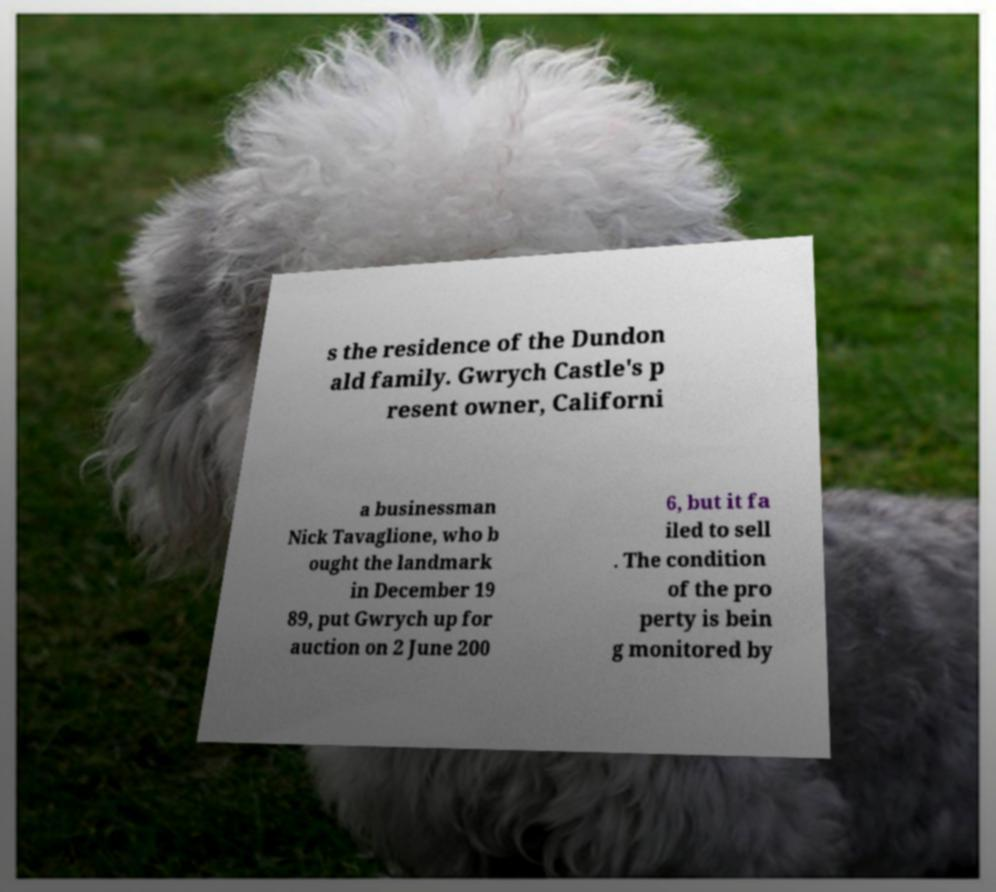I need the written content from this picture converted into text. Can you do that? s the residence of the Dundon ald family. Gwrych Castle's p resent owner, Californi a businessman Nick Tavaglione, who b ought the landmark in December 19 89, put Gwrych up for auction on 2 June 200 6, but it fa iled to sell . The condition of the pro perty is bein g monitored by 